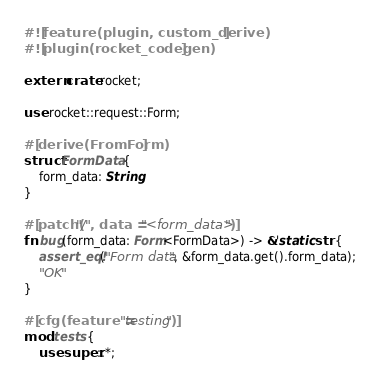<code> <loc_0><loc_0><loc_500><loc_500><_Rust_>#![feature(plugin, custom_derive)]
#![plugin(rocket_codegen)]

extern crate rocket;

use rocket::request::Form;

#[derive(FromForm)]
struct FormData {
    form_data: String,
}

#[patch("/", data = "<form_data>")]
fn bug(form_data: Form<FormData>) -> &'static str {
    assert_eq!("Form data", &form_data.get().form_data);
    "OK"
}

#[cfg(feature = "testing")]
mod tests {
    use super::*;</code> 